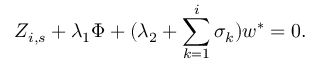Convert formula to latex. <formula><loc_0><loc_0><loc_500><loc_500>Z _ { i , s } + \lambda _ { 1 } \Phi + ( \lambda _ { 2 } + \sum _ { k = 1 } ^ { i } \sigma _ { k } ) w ^ { \ast } = 0 .</formula> 